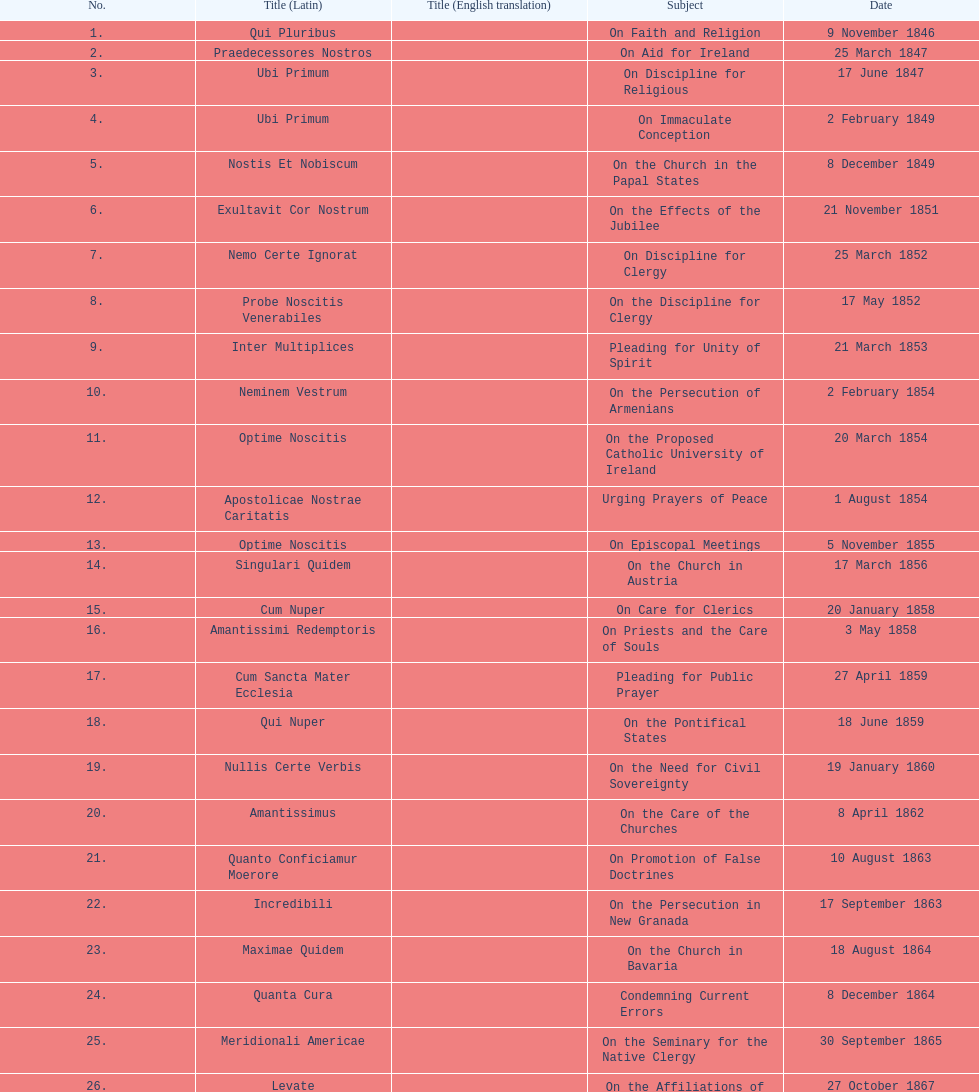What is the previous subject after on the effects of the jubilee? On the Church in the Papal States. 